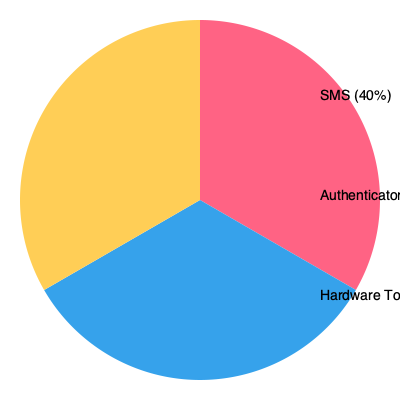Based on the pie chart showing multi-factor authentication methods used in your organization, which method would you recommend implementing in a new security automation and orchestration playbook to enhance the overall security posture while minimizing user friction? To answer this question, we need to consider several factors:

1. Security strength: Hardware tokens are generally considered the most secure, followed by authenticator apps, and then SMS.

2. User adoption and ease of use: SMS is often the easiest for users but least secure. Authenticator apps offer a good balance between security and usability.

3. Implementation in automation playbooks: Authenticator apps can be more easily integrated into automated systems compared to hardware tokens.

4. Current usage: The chart shows that SMS (40%) is the most used, followed by authenticator apps (35%), and hardware tokens (25%).

5. Improvement potential: Moving away from SMS would significantly enhance security.

Given these factors:

1. Hardware tokens, while most secure, may be challenging to implement in automation playbooks and have the lowest current adoption.

2. SMS is the least secure and should be phased out rather than expanded.

3. Authenticator apps offer the best balance of security, usability, and automation potential. They're also already familiar to a significant portion of users (35%).

Therefore, implementing authenticator apps in the new security automation and orchestration playbook would be the most effective choice. It enhances security compared to SMS, is easier to implement than hardware tokens, and builds on existing user familiarity.
Answer: Authenticator App 